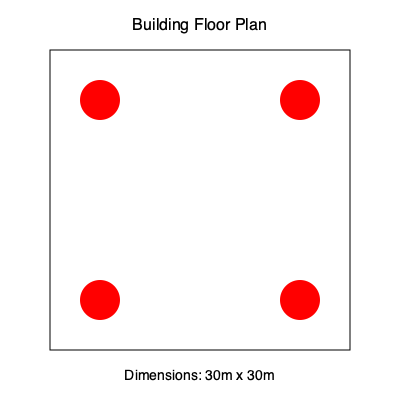Given a square building floor with dimensions 30m x 30m, what is the minimum number of fire sensors required to ensure complete coverage if each sensor has a circular detection range with a radius of 15m? To determine the optimal placement and minimum number of fire sensors, we need to follow these steps:

1. Understand the coverage area:
   - Each sensor covers a circular area with a radius of 15m.
   - The floor plan is a 30m x 30m square.

2. Calculate the diagonal of the square floor:
   - Using the Pythagorean theorem: $d = \sqrt{30^2 + 30^2} = \sqrt{1800} \approx 42.43m$

3. Analyze sensor placement:
   - Placing sensors in the corners would leave the center uncovered.
   - The optimal placement is at the midpoints of each side of the square.

4. Verify coverage:
   - With sensors at midpoints, the maximum distance between any point and a sensor is half the diagonal.
   - Half diagonal = $42.43m / 2 \approx 21.21m$
   - Since 21.21m > 15m (sensor radius), four sensors are not sufficient for complete coverage.

5. Determine minimum number of sensors:
   - We need to add a sensor at the center of the square.
   - This ensures that no point is further than 15m from a sensor.

6. Final configuration:
   - Four sensors at the midpoints of each side.
   - One sensor at the center.
   - Total: 5 sensors.

Therefore, the minimum number of sensors required for complete coverage is 5.
Answer: 5 sensors 